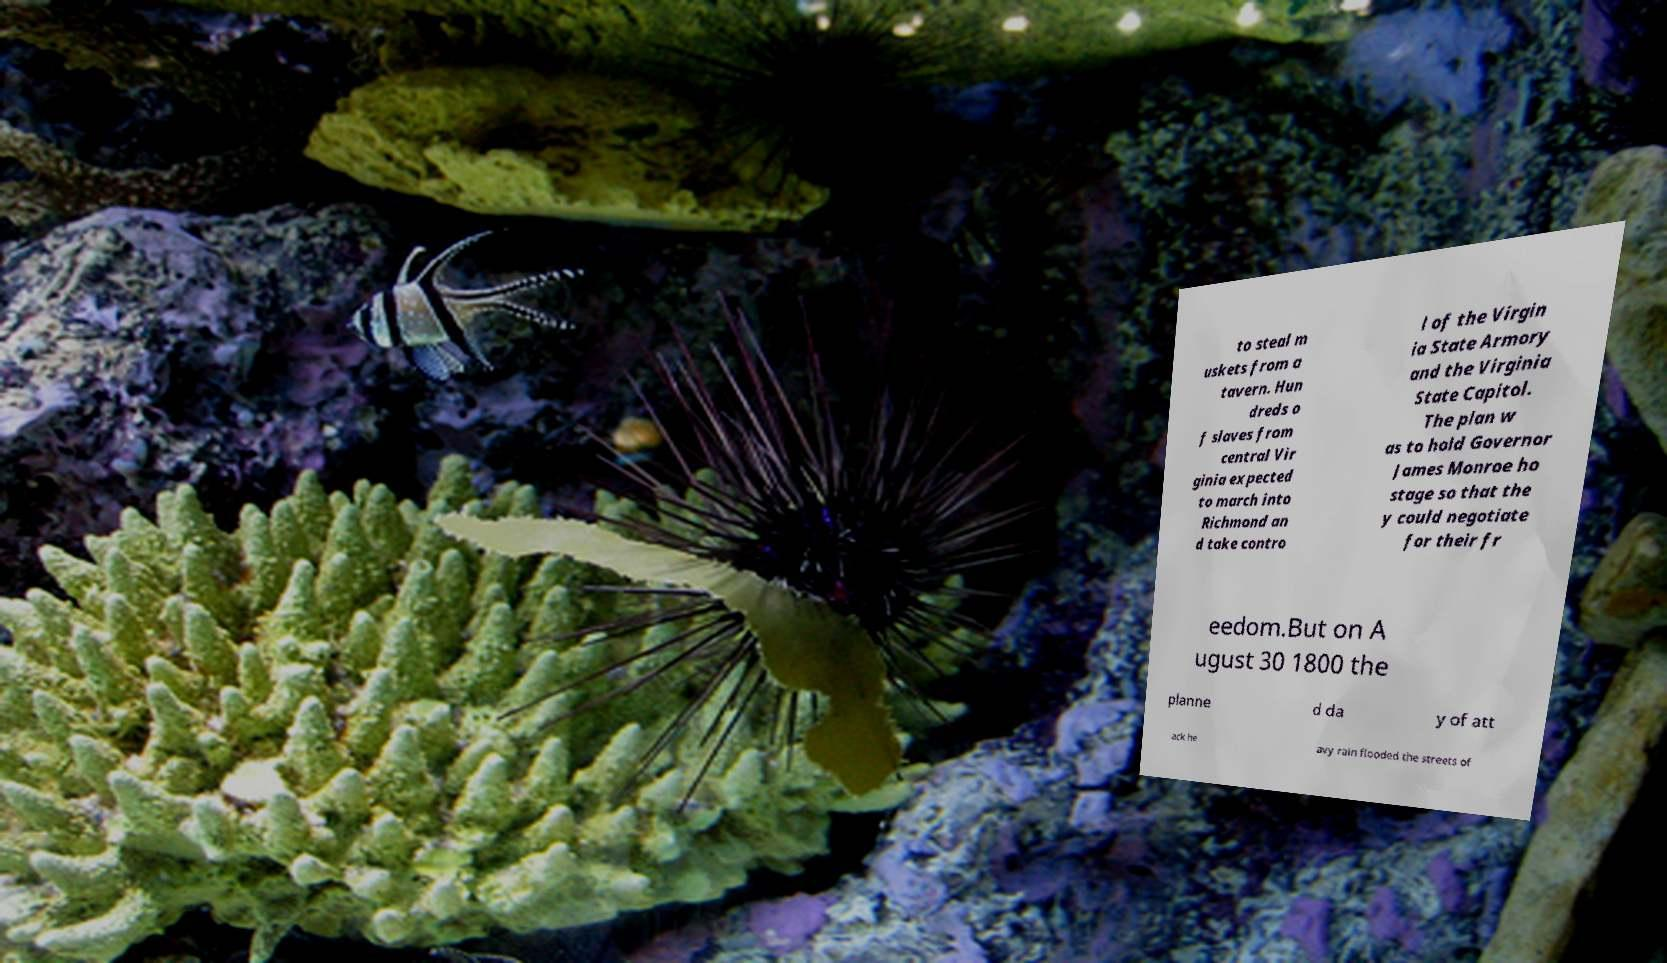Could you assist in decoding the text presented in this image and type it out clearly? to steal m uskets from a tavern. Hun dreds o f slaves from central Vir ginia expected to march into Richmond an d take contro l of the Virgin ia State Armory and the Virginia State Capitol. The plan w as to hold Governor James Monroe ho stage so that the y could negotiate for their fr eedom.But on A ugust 30 1800 the planne d da y of att ack he avy rain flooded the streets of 